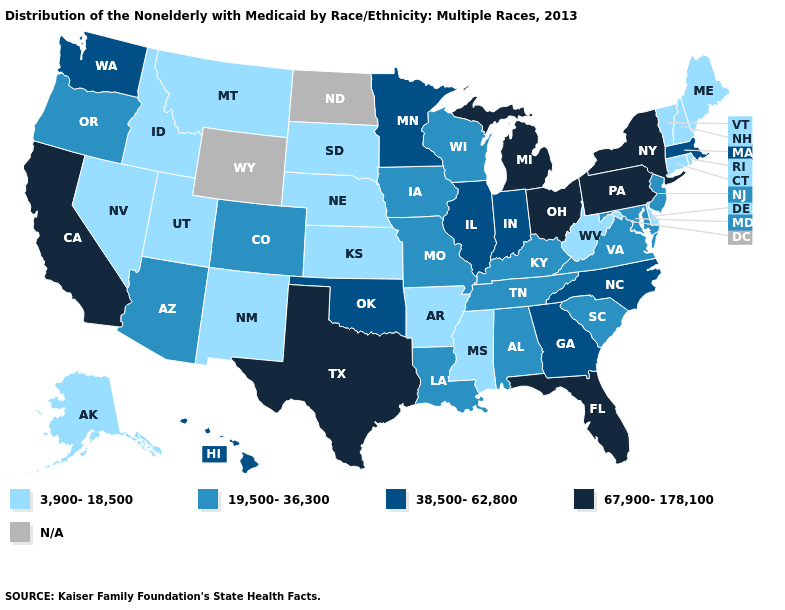Does the first symbol in the legend represent the smallest category?
Quick response, please. Yes. What is the value of Delaware?
Keep it brief. 3,900-18,500. Among the states that border Illinois , which have the lowest value?
Quick response, please. Iowa, Kentucky, Missouri, Wisconsin. What is the value of Ohio?
Write a very short answer. 67,900-178,100. What is the value of Florida?
Quick response, please. 67,900-178,100. Name the states that have a value in the range 67,900-178,100?
Short answer required. California, Florida, Michigan, New York, Ohio, Pennsylvania, Texas. What is the value of Georgia?
Give a very brief answer. 38,500-62,800. What is the value of Connecticut?
Keep it brief. 3,900-18,500. Which states have the lowest value in the USA?
Keep it brief. Alaska, Arkansas, Connecticut, Delaware, Idaho, Kansas, Maine, Mississippi, Montana, Nebraska, Nevada, New Hampshire, New Mexico, Rhode Island, South Dakota, Utah, Vermont, West Virginia. What is the lowest value in the USA?
Short answer required. 3,900-18,500. What is the value of Iowa?
Keep it brief. 19,500-36,300. What is the highest value in the West ?
Give a very brief answer. 67,900-178,100. What is the value of Arkansas?
Give a very brief answer. 3,900-18,500. What is the value of New York?
Answer briefly. 67,900-178,100. Among the states that border Delaware , which have the lowest value?
Quick response, please. Maryland, New Jersey. 